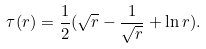<formula> <loc_0><loc_0><loc_500><loc_500>\tau ( r ) = \frac { 1 } { 2 } ( \sqrt { r } - \frac { 1 } { \sqrt { r } } + \ln { r } ) .</formula> 